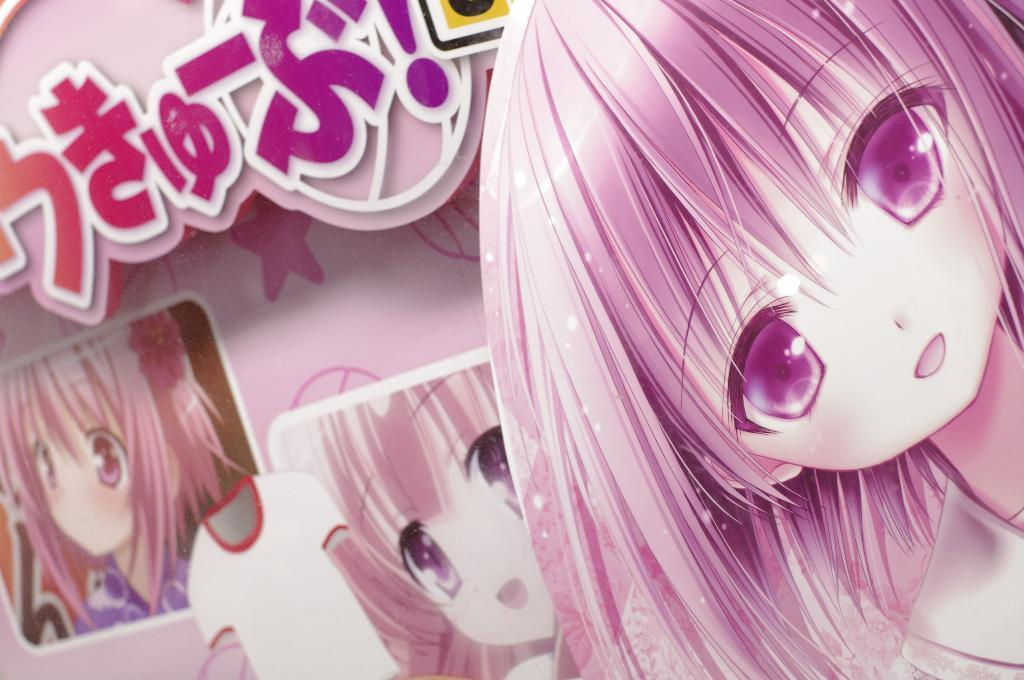What type of image is being described? The image is an animated picture. Who or what is the main subject in the image? There is a girl in the image. What is the girl wearing in the image? There is a t-shirt in the image. Are there any words or letters visible in the image? Yes, there are letters in the image. How many photos of the girl are present in the image? There are two photos of the girl in the image. What type of plant is being used as a prop by the giants in the image? There are no giants or plants present in the image. What achievement has the girl accomplished, as depicted in the image? The image does not show any specific achievements or accomplishments of the girl. 